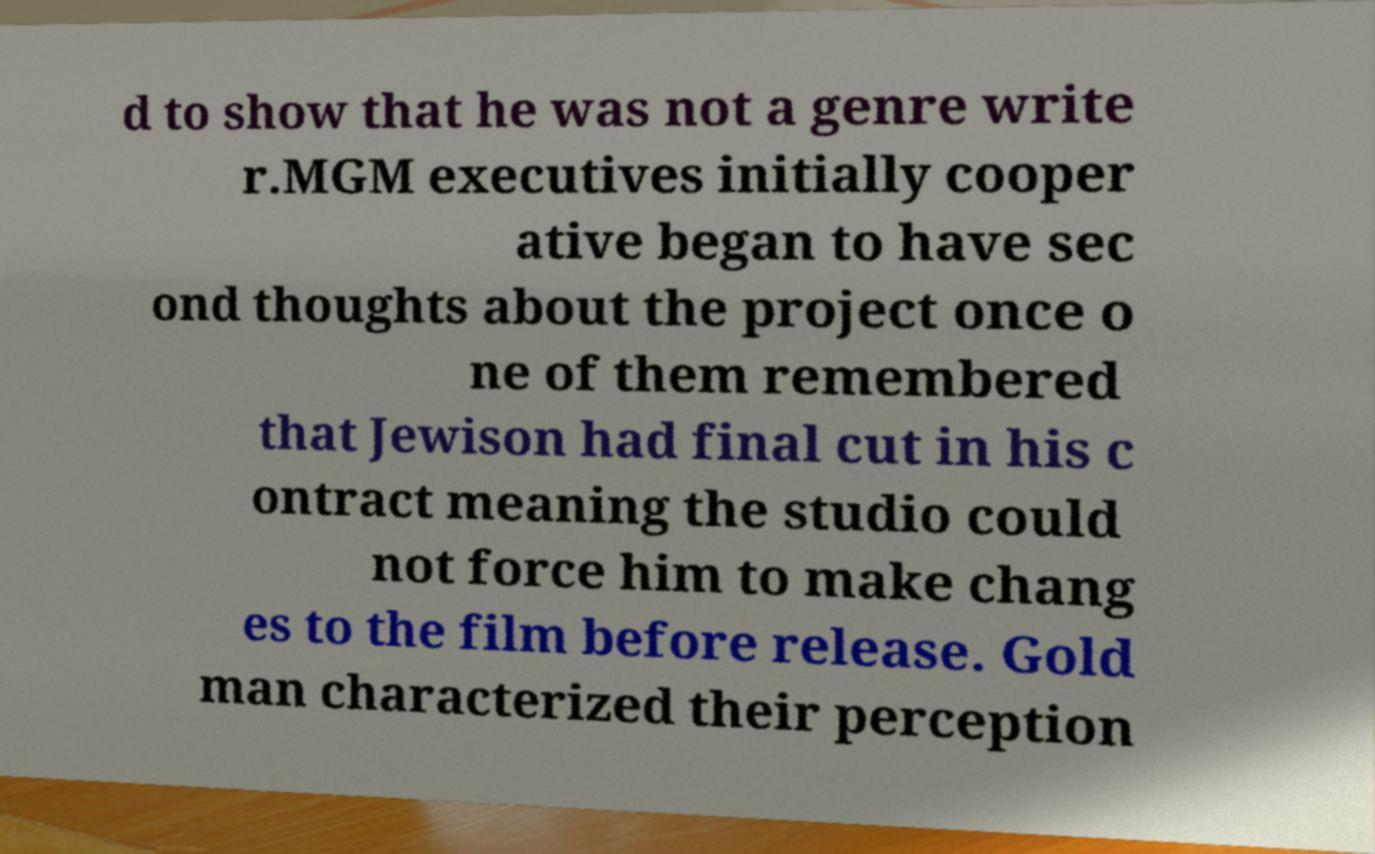Can you accurately transcribe the text from the provided image for me? d to show that he was not a genre write r.MGM executives initially cooper ative began to have sec ond thoughts about the project once o ne of them remembered that Jewison had final cut in his c ontract meaning the studio could not force him to make chang es to the film before release. Gold man characterized their perception 